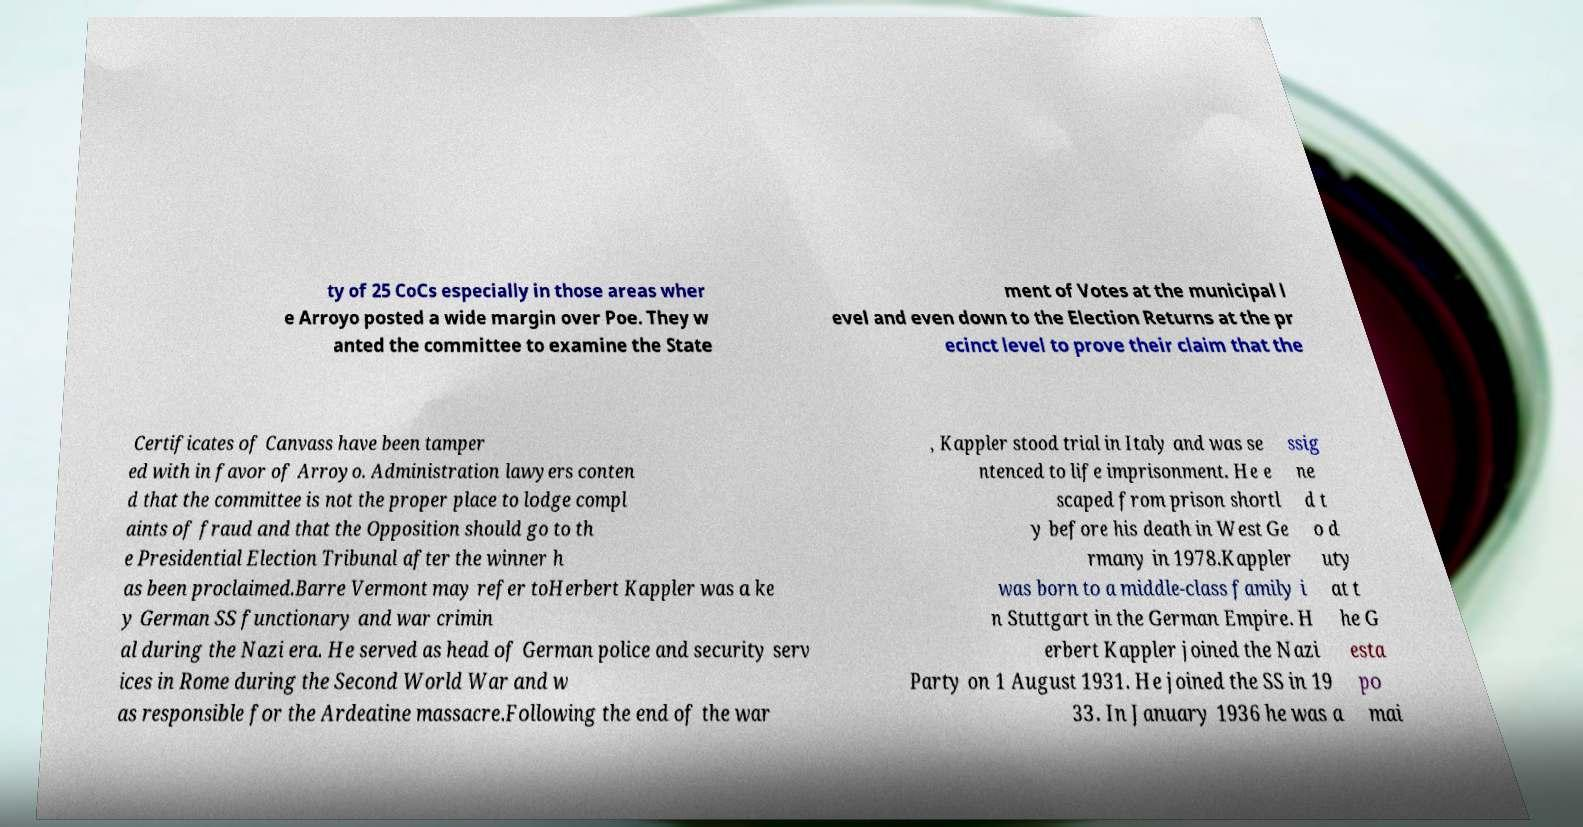Please identify and transcribe the text found in this image. ty of 25 CoCs especially in those areas wher e Arroyo posted a wide margin over Poe. They w anted the committee to examine the State ment of Votes at the municipal l evel and even down to the Election Returns at the pr ecinct level to prove their claim that the Certificates of Canvass have been tamper ed with in favor of Arroyo. Administration lawyers conten d that the committee is not the proper place to lodge compl aints of fraud and that the Opposition should go to th e Presidential Election Tribunal after the winner h as been proclaimed.Barre Vermont may refer toHerbert Kappler was a ke y German SS functionary and war crimin al during the Nazi era. He served as head of German police and security serv ices in Rome during the Second World War and w as responsible for the Ardeatine massacre.Following the end of the war , Kappler stood trial in Italy and was se ntenced to life imprisonment. He e scaped from prison shortl y before his death in West Ge rmany in 1978.Kappler was born to a middle-class family i n Stuttgart in the German Empire. H erbert Kappler joined the Nazi Party on 1 August 1931. He joined the SS in 19 33. In January 1936 he was a ssig ne d t o d uty at t he G esta po mai 